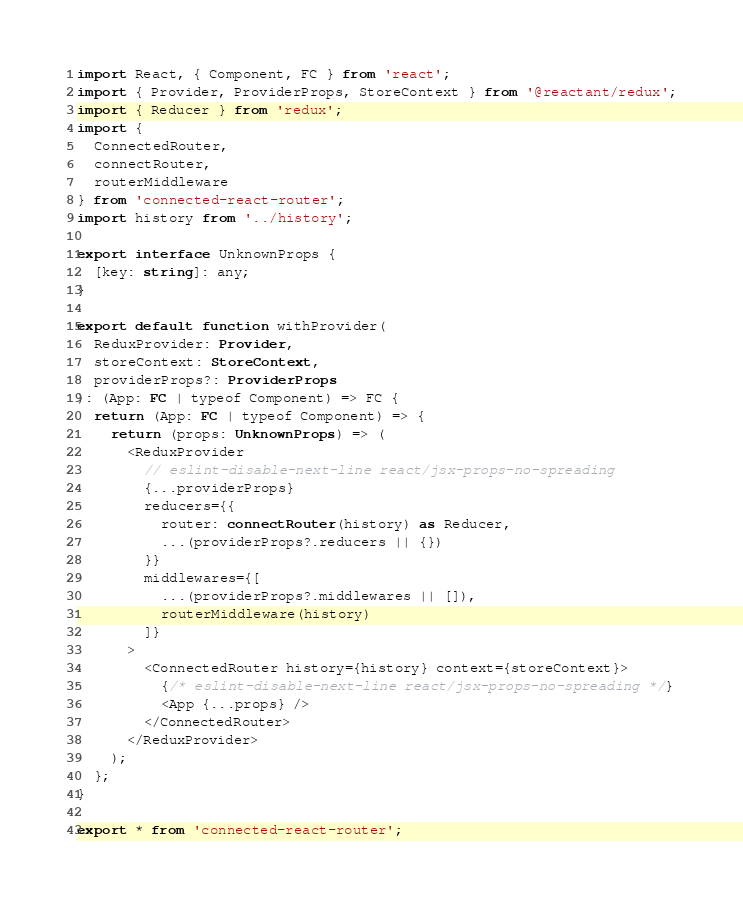Convert code to text. <code><loc_0><loc_0><loc_500><loc_500><_TypeScript_>import React, { Component, FC } from 'react';
import { Provider, ProviderProps, StoreContext } from '@reactant/redux';
import { Reducer } from 'redux';
import {
  ConnectedRouter,
  connectRouter,
  routerMiddleware
} from 'connected-react-router';
import history from '../history';

export interface UnknownProps {
  [key: string]: any;
}

export default function withProvider(
  ReduxProvider: Provider,
  storeContext: StoreContext,
  providerProps?: ProviderProps
): (App: FC | typeof Component) => FC {
  return (App: FC | typeof Component) => {
    return (props: UnknownProps) => (
      <ReduxProvider
        // eslint-disable-next-line react/jsx-props-no-spreading
        {...providerProps}
        reducers={{
          router: connectRouter(history) as Reducer,
          ...(providerProps?.reducers || {})
        }}
        middlewares={[
          ...(providerProps?.middlewares || []),
          routerMiddleware(history)
        ]}
      >
        <ConnectedRouter history={history} context={storeContext}>
          {/* eslint-disable-next-line react/jsx-props-no-spreading */}
          <App {...props} />
        </ConnectedRouter>
      </ReduxProvider>
    );
  };
}

export * from 'connected-react-router';
</code> 